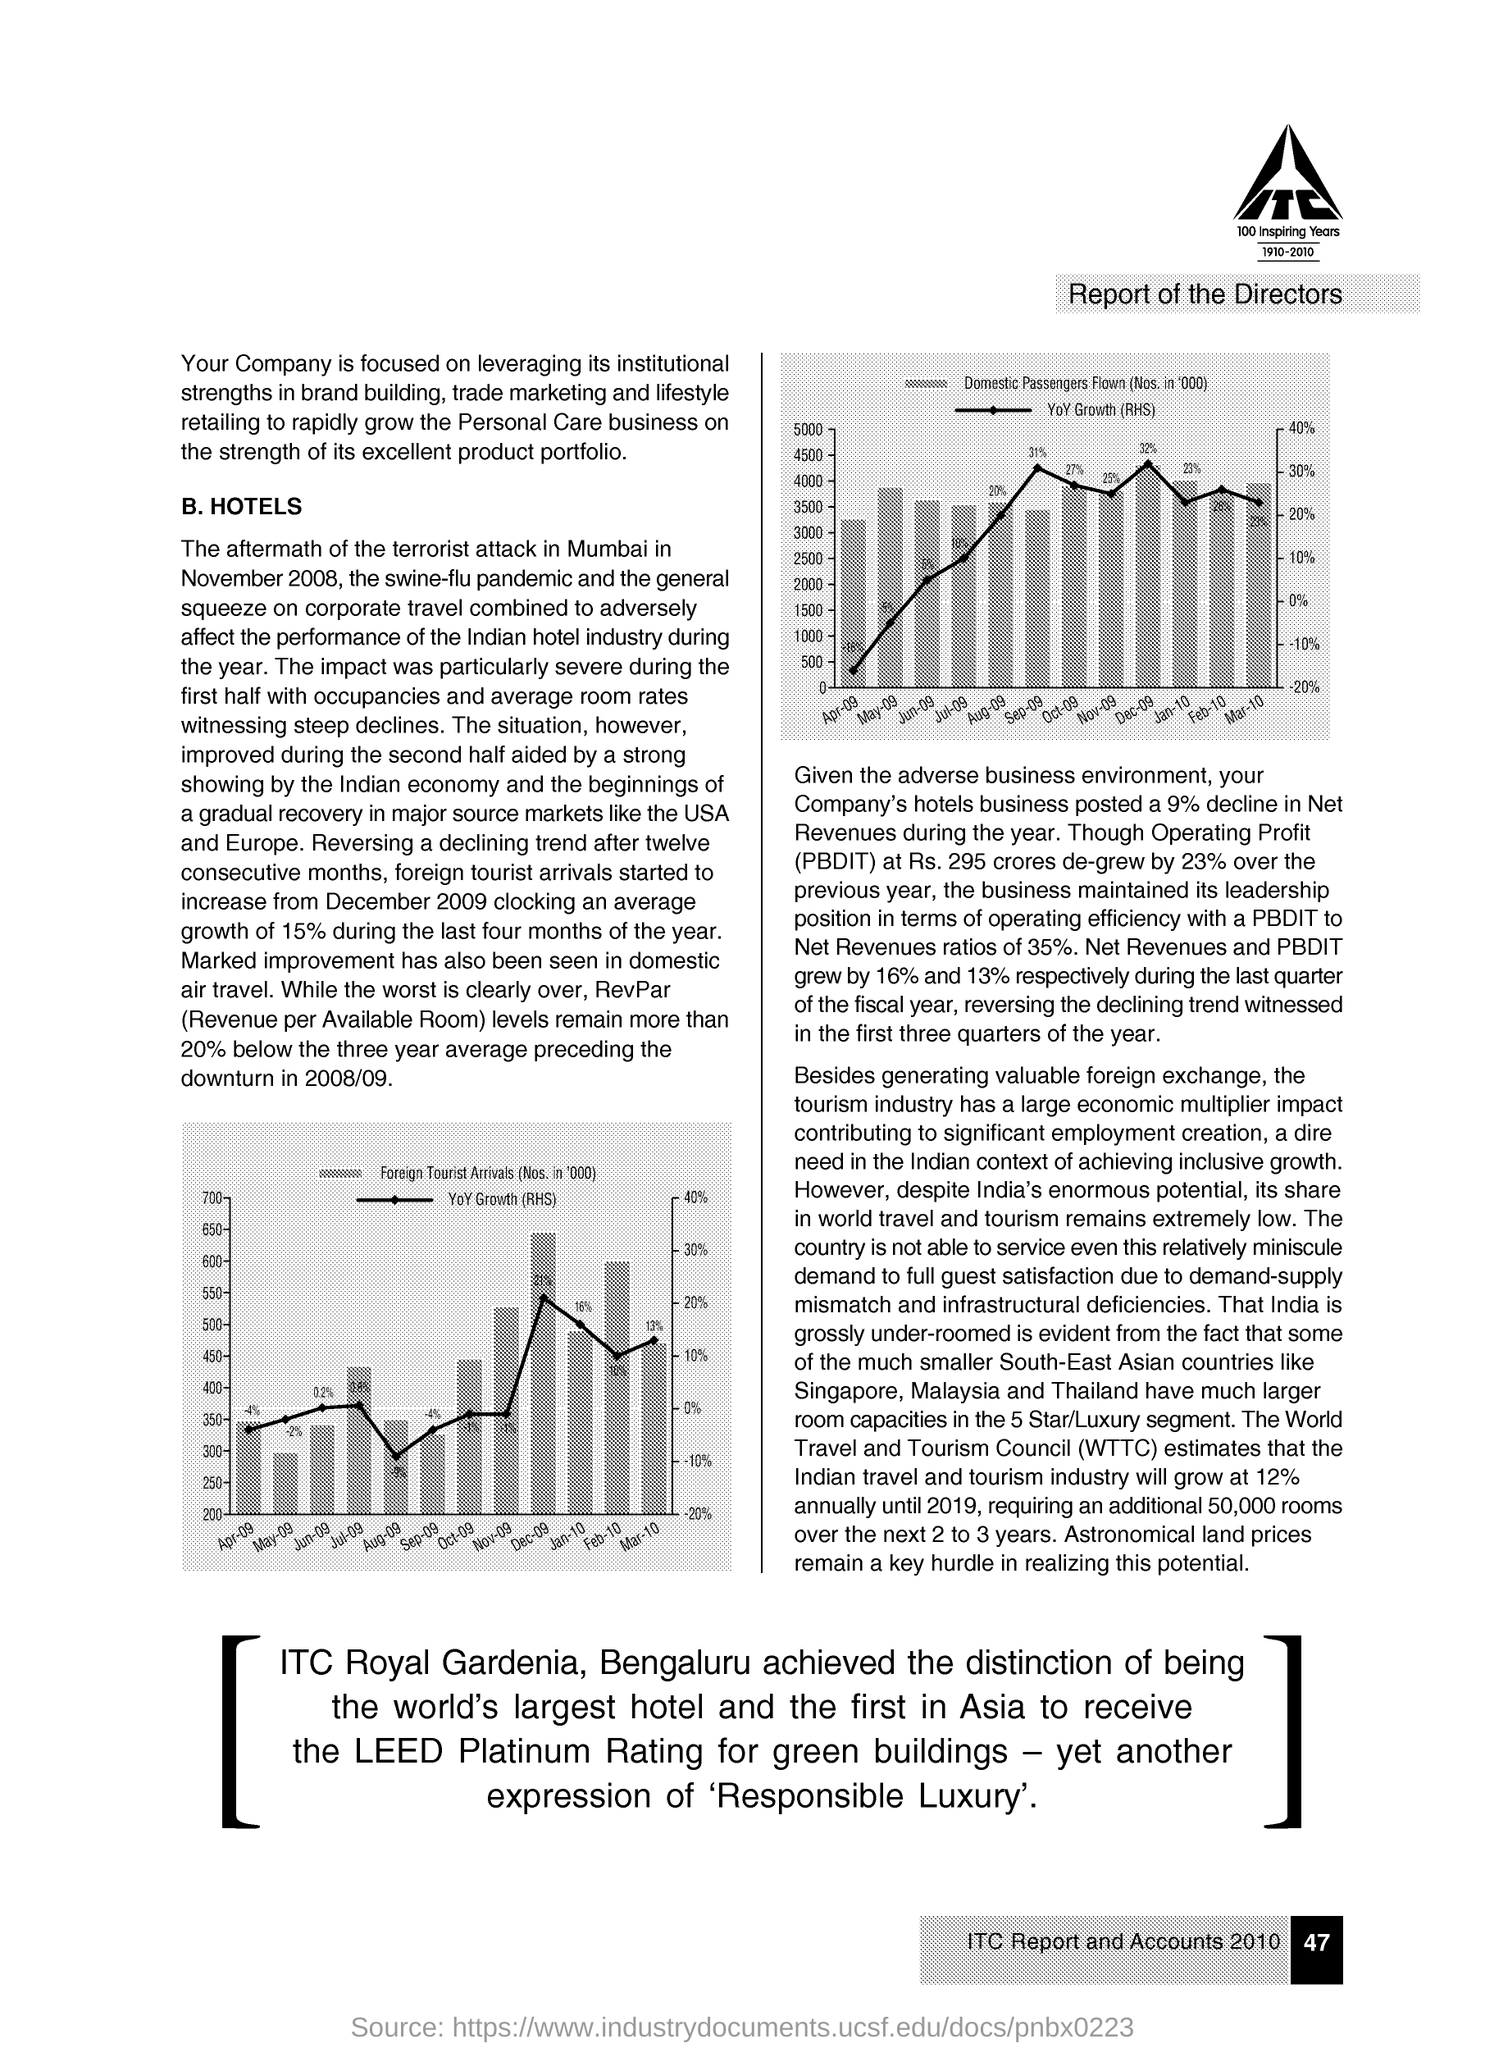What does WTTC stand for?
Offer a terse response. World Travel and Tourism Council. 